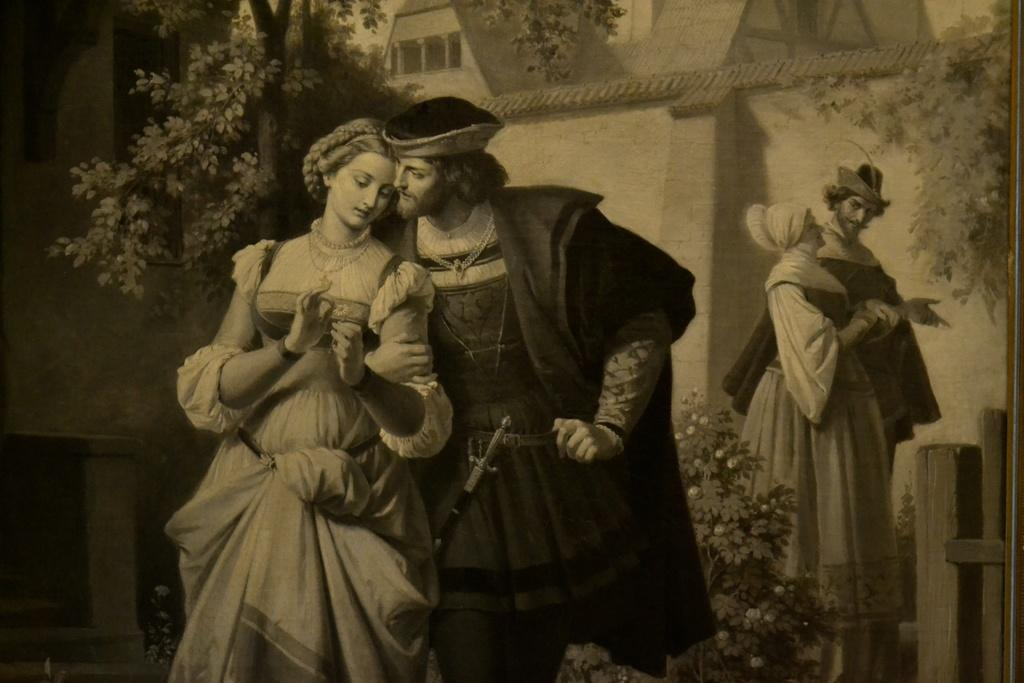What is the main subject of the image? The main subject of the image is a painting. What elements are depicted in the painting? The painting contains people, trees, and houses. What type of chin can be seen on the people in the painting? There is no chin visible in the painting, as it is a two-dimensional representation of people, trees, and houses. 